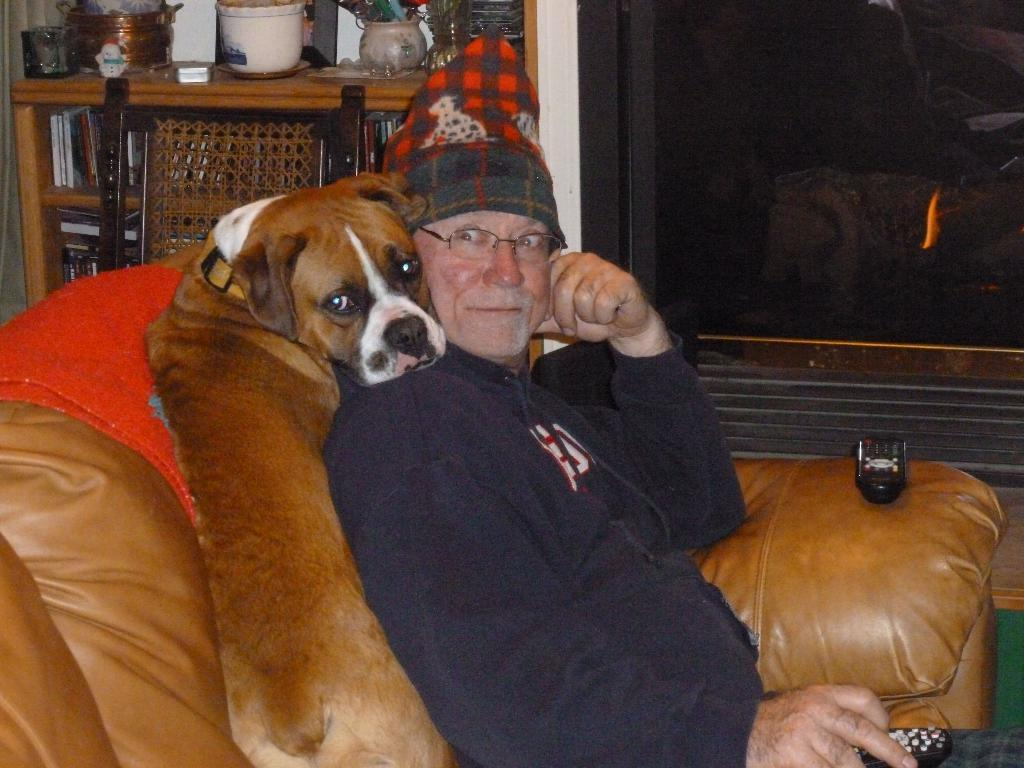Who is present in the image? There is a man and a dog in the image. What are they doing in the image? Both the man and the dog are on a sofa. What is the man holding in the image? The man is holding a remote. Can you describe the man's appearance? The man is wearing glasses (specs) and a cap. What can be seen in the background of the image? There is a chair and utensils in the background of the image. How does the dog react to the man's crook in the image? There is no crook present in the image, and the dog is not reacting to anything in particular. 